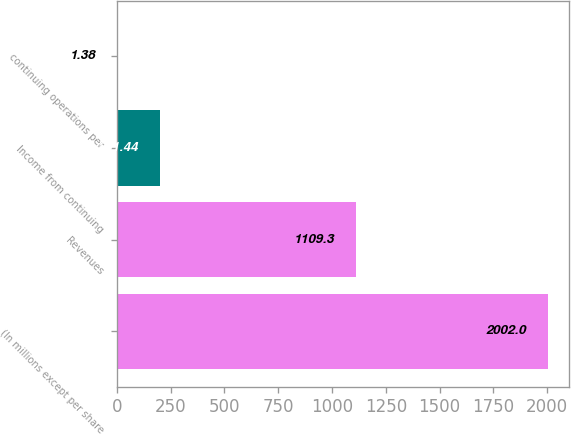<chart> <loc_0><loc_0><loc_500><loc_500><bar_chart><fcel>(In millions except per share<fcel>Revenues<fcel>Income from continuing<fcel>continuing operations per<nl><fcel>2002<fcel>1109.3<fcel>201.44<fcel>1.38<nl></chart> 